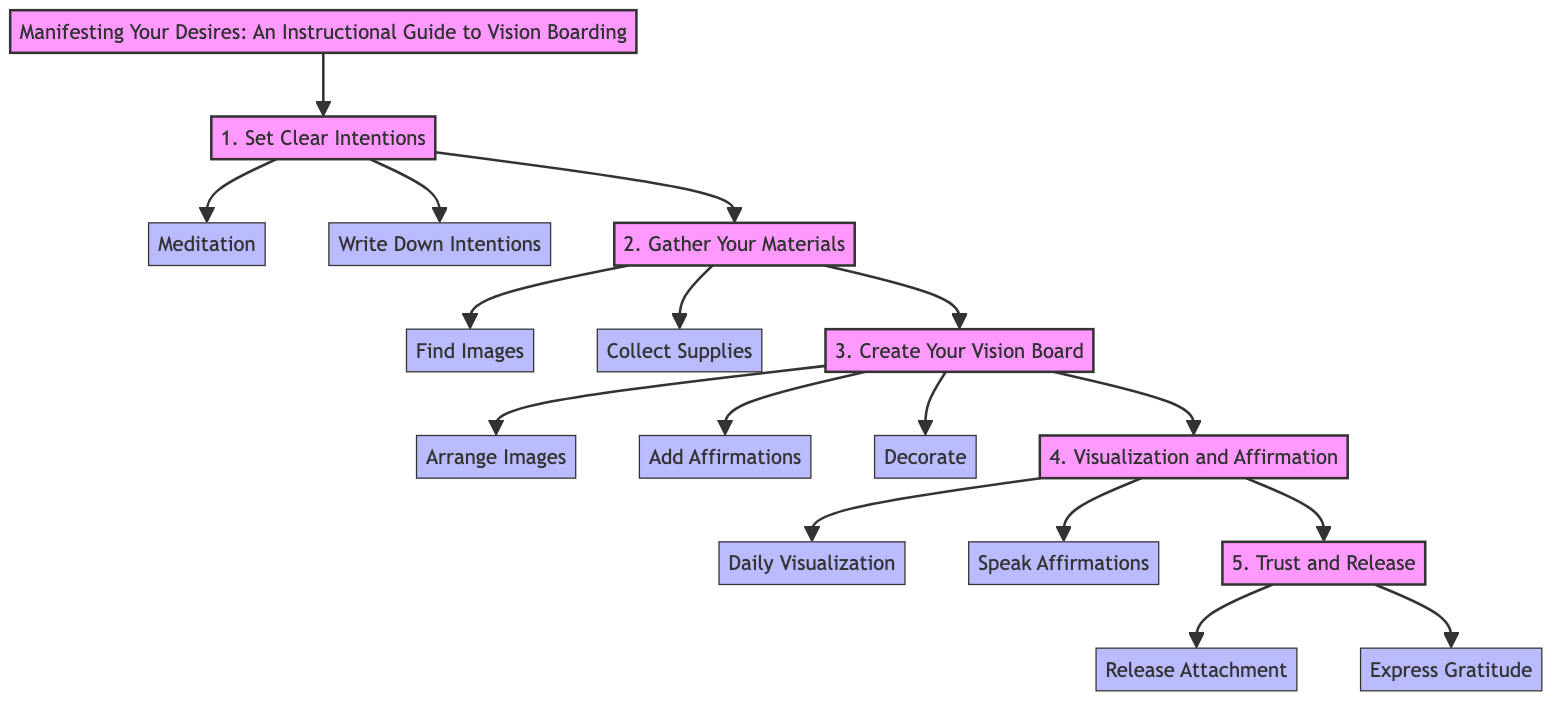What is the title of the diagram? The title node in the diagram is the starting point. It states "Manifesting Your Desires: An Instructional Guide to Vision Boarding".
Answer: Manifesting Your Desires: An Instructional Guide to Vision Boarding How many main steps are there in the diagram? The diagram lists five main steps. By counting the nodes connecting directly from the title to the steps, we see there are five (Set Clear Intentions, Gather Your Materials, Create Your Vision Board, Visualization and Affirmation, Trust and Release).
Answer: 5 Which step follows "Gather Your Materials"? The diagram indicates the flow from "Gather Your Materials" to "Create Your Vision Board". To find this, one simply follows the arrows leading from the second step.
Answer: Create Your Vision Board What actions are included in the first step? The first step is "Set Clear Intentions", which has two actions connected to it: "Meditation" and "Write Down Intentions". Both actions are directly listed below this step.
Answer: Meditation, Write Down Intentions What two actions are listed under "Trust and Release"? The final step "Trust and Release" includes two actions: "Release Attachment" and "Express Gratitude". This can be determined by tracing the last step in the flow chart.
Answer: Release Attachment, Express Gratitude What is the first action one should take according to the diagram? The diagram indicates that the first action associated with step one is "Meditation". Following the flow, this is the first connection linked under "Set Clear Intentions".
Answer: Meditation What is the last main step in the process? By examining the flow of the diagram, the last main step is "Trust and Release", which can be followed as the last node after "Visualization and Affirmation".
Answer: Trust and Release How many actions follow after "Create Your Vision Board"? There are three actions listed after "Create Your Vision Board", which are "Arrange Images", "Add Affirmations", and "Decorate". Counting the nodes branching from this step confirms there are three.
Answer: 3 Which actions are included in the step "Visualization and Affirmation"? The step "Visualization and Affirmation" has two actions associated with it: "Daily Visualization" and "Speak Affirmations". This is derived from identifying the connections under this specific step.
Answer: Daily Visualization, Speak Affirmations 